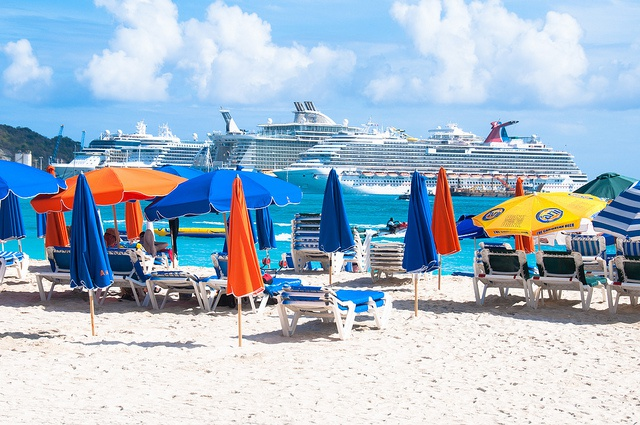Describe the objects in this image and their specific colors. I can see boat in lightblue, white, and gray tones, boat in lightblue, lightgray, and gray tones, umbrella in lightblue, blue, gray, navy, and darkblue tones, boat in lightblue, white, teal, and gray tones, and umbrella in lightblue, gold, and orange tones in this image. 